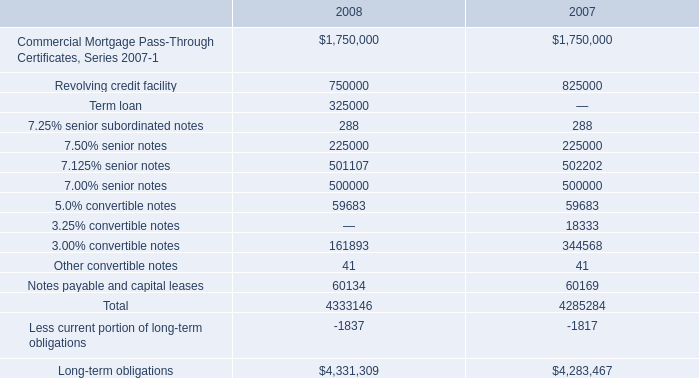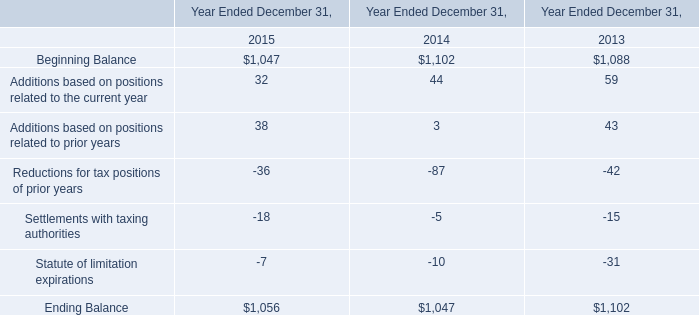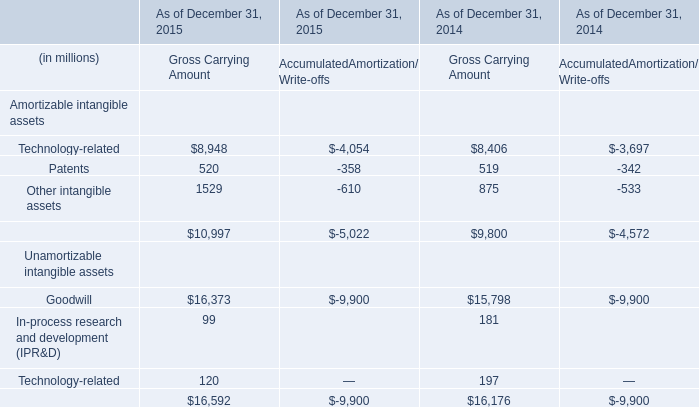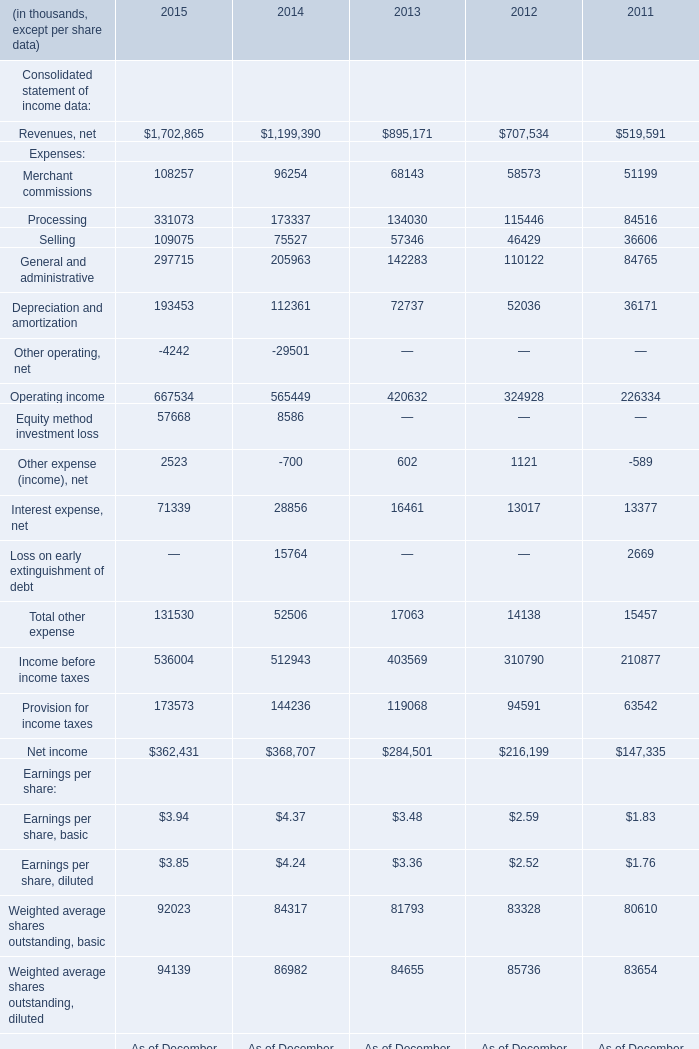In the year with largest amount of Revenues, net, what's the sum of Expenses? (in thousand) 
Computations: (((((108257 + 331073) + 109075) + 297715) + 193453) + -4242)
Answer: 1035331.0. 